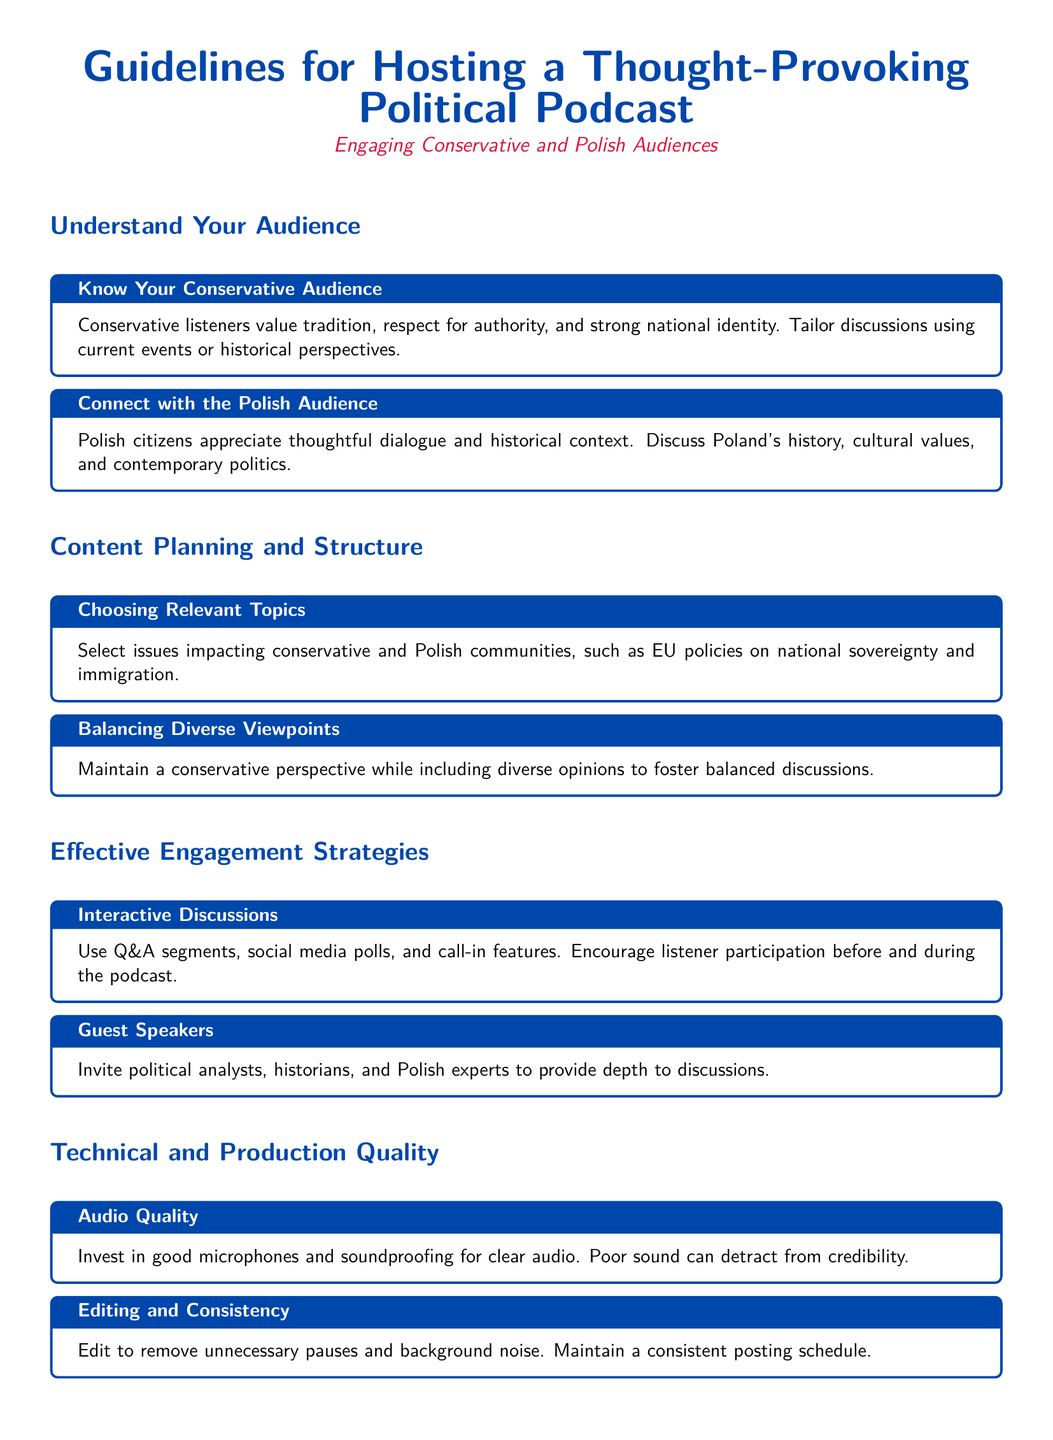What values do conservative listeners appreciate? The document states that conservative listeners value tradition, respect for authority, and strong national identity.
Answer: Tradition, respect for authority, strong national identity What should be focused on when connecting with the Polish audience? The document emphasizes that Polish citizens appreciate thoughtful dialogue and historical context.
Answer: Thoughtful dialogue and historical context What types of issues should be selected for relevant topics? The document suggests selecting issues impacting conservative and Polish communities, such as EU policies on national sovereignty and immigration.
Answer: EU policies on national sovereignty and immigration How should diverse viewpoints be balanced? The document advises maintaining a conservative perspective while including diverse opinions to foster balanced discussions.
Answer: Maintain a conservative perspective What is crucial for audio quality in podcasting? The document states that investing in good microphones and soundproofing is crucial for clear audio.
Answer: Good microphones and soundproofing What should be done to ensure editing and consistency? The document recommends editing to remove unnecessary pauses and background noise, and maintaining a consistent posting schedule.
Answer: Remove unnecessary pauses, maintain consistent posting schedule How can promotion through social media be beneficial? The document indicates that promoting through platforms like Facebook, Twitter, and LinkedIn helps engage with Polish and conservative online communities.
Answer: Engaging with Polish and conservative online communities What is a suggested strategy for engaging listeners? The document includes using Q&A segments, social media polls, and call-in features as engaging strategies.
Answer: Q&A segments, social media polls, call-in features 